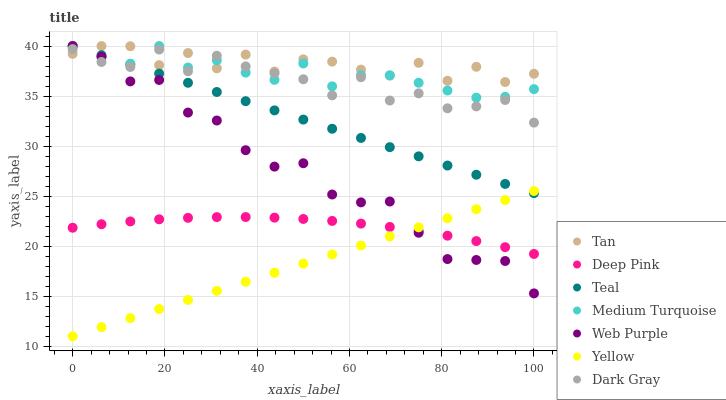Does Yellow have the minimum area under the curve?
Answer yes or no. Yes. Does Tan have the maximum area under the curve?
Answer yes or no. Yes. Does Teal have the minimum area under the curve?
Answer yes or no. No. Does Teal have the maximum area under the curve?
Answer yes or no. No. Is Yellow the smoothest?
Answer yes or no. Yes. Is Tan the roughest?
Answer yes or no. Yes. Is Teal the smoothest?
Answer yes or no. No. Is Teal the roughest?
Answer yes or no. No. Does Yellow have the lowest value?
Answer yes or no. Yes. Does Teal have the lowest value?
Answer yes or no. No. Does Tan have the highest value?
Answer yes or no. Yes. Does Yellow have the highest value?
Answer yes or no. No. Is Deep Pink less than Dark Gray?
Answer yes or no. Yes. Is Dark Gray greater than Yellow?
Answer yes or no. Yes. Does Dark Gray intersect Teal?
Answer yes or no. Yes. Is Dark Gray less than Teal?
Answer yes or no. No. Is Dark Gray greater than Teal?
Answer yes or no. No. Does Deep Pink intersect Dark Gray?
Answer yes or no. No. 